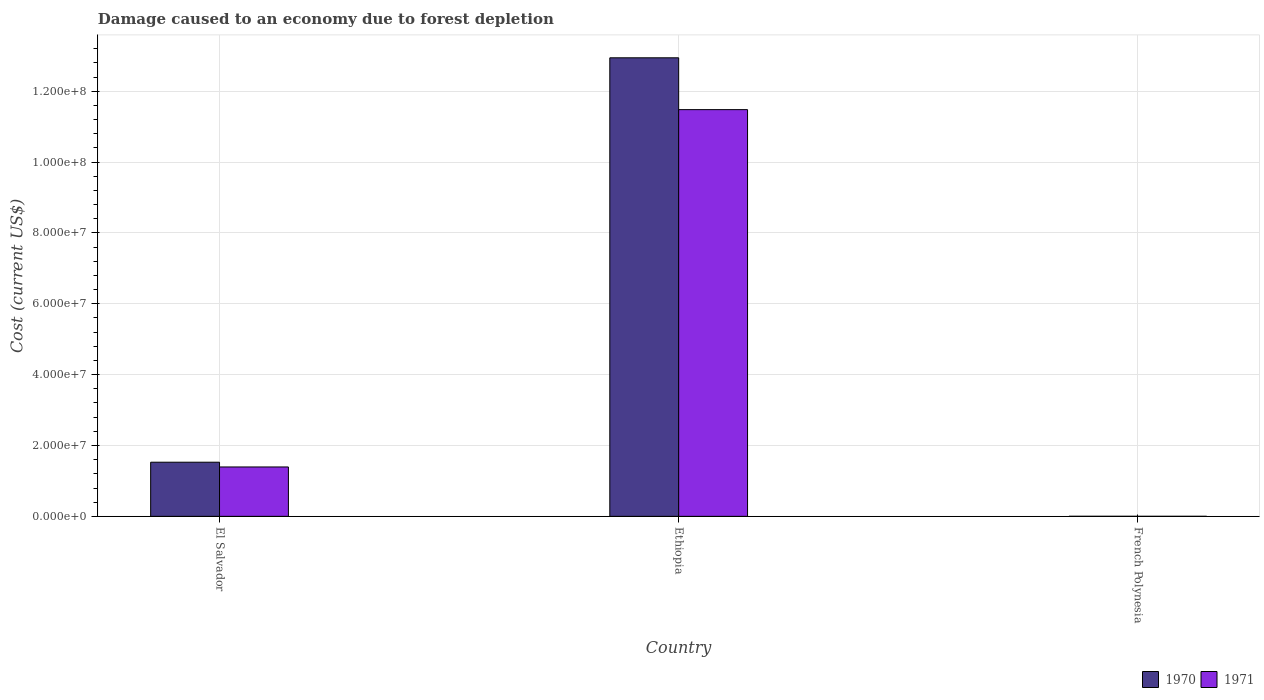How many different coloured bars are there?
Offer a very short reply. 2. What is the label of the 3rd group of bars from the left?
Provide a succinct answer. French Polynesia. What is the cost of damage caused due to forest depletion in 1970 in French Polynesia?
Ensure brevity in your answer.  1.18e+04. Across all countries, what is the maximum cost of damage caused due to forest depletion in 1970?
Provide a succinct answer. 1.29e+08. Across all countries, what is the minimum cost of damage caused due to forest depletion in 1971?
Your answer should be compact. 9061.15. In which country was the cost of damage caused due to forest depletion in 1970 maximum?
Your answer should be very brief. Ethiopia. In which country was the cost of damage caused due to forest depletion in 1971 minimum?
Your response must be concise. French Polynesia. What is the total cost of damage caused due to forest depletion in 1971 in the graph?
Provide a succinct answer. 1.29e+08. What is the difference between the cost of damage caused due to forest depletion in 1970 in El Salvador and that in French Polynesia?
Your answer should be compact. 1.53e+07. What is the difference between the cost of damage caused due to forest depletion in 1970 in El Salvador and the cost of damage caused due to forest depletion in 1971 in French Polynesia?
Your response must be concise. 1.53e+07. What is the average cost of damage caused due to forest depletion in 1970 per country?
Provide a succinct answer. 4.82e+07. What is the difference between the cost of damage caused due to forest depletion of/in 1970 and cost of damage caused due to forest depletion of/in 1971 in French Polynesia?
Provide a succinct answer. 2690.05. What is the ratio of the cost of damage caused due to forest depletion in 1971 in Ethiopia to that in French Polynesia?
Make the answer very short. 1.27e+04. Is the difference between the cost of damage caused due to forest depletion in 1970 in El Salvador and French Polynesia greater than the difference between the cost of damage caused due to forest depletion in 1971 in El Salvador and French Polynesia?
Your response must be concise. Yes. What is the difference between the highest and the second highest cost of damage caused due to forest depletion in 1970?
Keep it short and to the point. -1.53e+07. What is the difference between the highest and the lowest cost of damage caused due to forest depletion in 1970?
Your answer should be very brief. 1.29e+08. What does the 2nd bar from the right in Ethiopia represents?
Your response must be concise. 1970. How many bars are there?
Offer a very short reply. 6. What is the difference between two consecutive major ticks on the Y-axis?
Your response must be concise. 2.00e+07. Are the values on the major ticks of Y-axis written in scientific E-notation?
Provide a short and direct response. Yes. Does the graph contain any zero values?
Give a very brief answer. No. What is the title of the graph?
Keep it short and to the point. Damage caused to an economy due to forest depletion. Does "1965" appear as one of the legend labels in the graph?
Give a very brief answer. No. What is the label or title of the X-axis?
Provide a succinct answer. Country. What is the label or title of the Y-axis?
Your response must be concise. Cost (current US$). What is the Cost (current US$) of 1970 in El Salvador?
Give a very brief answer. 1.53e+07. What is the Cost (current US$) of 1971 in El Salvador?
Make the answer very short. 1.39e+07. What is the Cost (current US$) in 1970 in Ethiopia?
Make the answer very short. 1.29e+08. What is the Cost (current US$) in 1971 in Ethiopia?
Offer a terse response. 1.15e+08. What is the Cost (current US$) of 1970 in French Polynesia?
Ensure brevity in your answer.  1.18e+04. What is the Cost (current US$) of 1971 in French Polynesia?
Your answer should be compact. 9061.15. Across all countries, what is the maximum Cost (current US$) in 1970?
Ensure brevity in your answer.  1.29e+08. Across all countries, what is the maximum Cost (current US$) of 1971?
Your answer should be very brief. 1.15e+08. Across all countries, what is the minimum Cost (current US$) of 1970?
Your answer should be very brief. 1.18e+04. Across all countries, what is the minimum Cost (current US$) in 1971?
Your answer should be compact. 9061.15. What is the total Cost (current US$) of 1970 in the graph?
Keep it short and to the point. 1.45e+08. What is the total Cost (current US$) of 1971 in the graph?
Your answer should be very brief. 1.29e+08. What is the difference between the Cost (current US$) of 1970 in El Salvador and that in Ethiopia?
Ensure brevity in your answer.  -1.14e+08. What is the difference between the Cost (current US$) of 1971 in El Salvador and that in Ethiopia?
Give a very brief answer. -1.01e+08. What is the difference between the Cost (current US$) in 1970 in El Salvador and that in French Polynesia?
Your answer should be very brief. 1.53e+07. What is the difference between the Cost (current US$) in 1971 in El Salvador and that in French Polynesia?
Offer a very short reply. 1.39e+07. What is the difference between the Cost (current US$) in 1970 in Ethiopia and that in French Polynesia?
Make the answer very short. 1.29e+08. What is the difference between the Cost (current US$) in 1971 in Ethiopia and that in French Polynesia?
Your answer should be very brief. 1.15e+08. What is the difference between the Cost (current US$) in 1970 in El Salvador and the Cost (current US$) in 1971 in Ethiopia?
Your response must be concise. -9.95e+07. What is the difference between the Cost (current US$) of 1970 in El Salvador and the Cost (current US$) of 1971 in French Polynesia?
Provide a succinct answer. 1.53e+07. What is the difference between the Cost (current US$) in 1970 in Ethiopia and the Cost (current US$) in 1971 in French Polynesia?
Your answer should be very brief. 1.29e+08. What is the average Cost (current US$) of 1970 per country?
Your answer should be compact. 4.82e+07. What is the average Cost (current US$) in 1971 per country?
Ensure brevity in your answer.  4.29e+07. What is the difference between the Cost (current US$) of 1970 and Cost (current US$) of 1971 in El Salvador?
Make the answer very short. 1.34e+06. What is the difference between the Cost (current US$) of 1970 and Cost (current US$) of 1971 in Ethiopia?
Your response must be concise. 1.46e+07. What is the difference between the Cost (current US$) of 1970 and Cost (current US$) of 1971 in French Polynesia?
Offer a terse response. 2690.05. What is the ratio of the Cost (current US$) in 1970 in El Salvador to that in Ethiopia?
Provide a short and direct response. 0.12. What is the ratio of the Cost (current US$) of 1971 in El Salvador to that in Ethiopia?
Provide a succinct answer. 0.12. What is the ratio of the Cost (current US$) in 1970 in El Salvador to that in French Polynesia?
Offer a very short reply. 1300.42. What is the ratio of the Cost (current US$) in 1971 in El Salvador to that in French Polynesia?
Provide a succinct answer. 1538.5. What is the ratio of the Cost (current US$) in 1970 in Ethiopia to that in French Polynesia?
Your response must be concise. 1.10e+04. What is the ratio of the Cost (current US$) of 1971 in Ethiopia to that in French Polynesia?
Your answer should be very brief. 1.27e+04. What is the difference between the highest and the second highest Cost (current US$) of 1970?
Your response must be concise. 1.14e+08. What is the difference between the highest and the second highest Cost (current US$) of 1971?
Your response must be concise. 1.01e+08. What is the difference between the highest and the lowest Cost (current US$) of 1970?
Provide a succinct answer. 1.29e+08. What is the difference between the highest and the lowest Cost (current US$) in 1971?
Your response must be concise. 1.15e+08. 